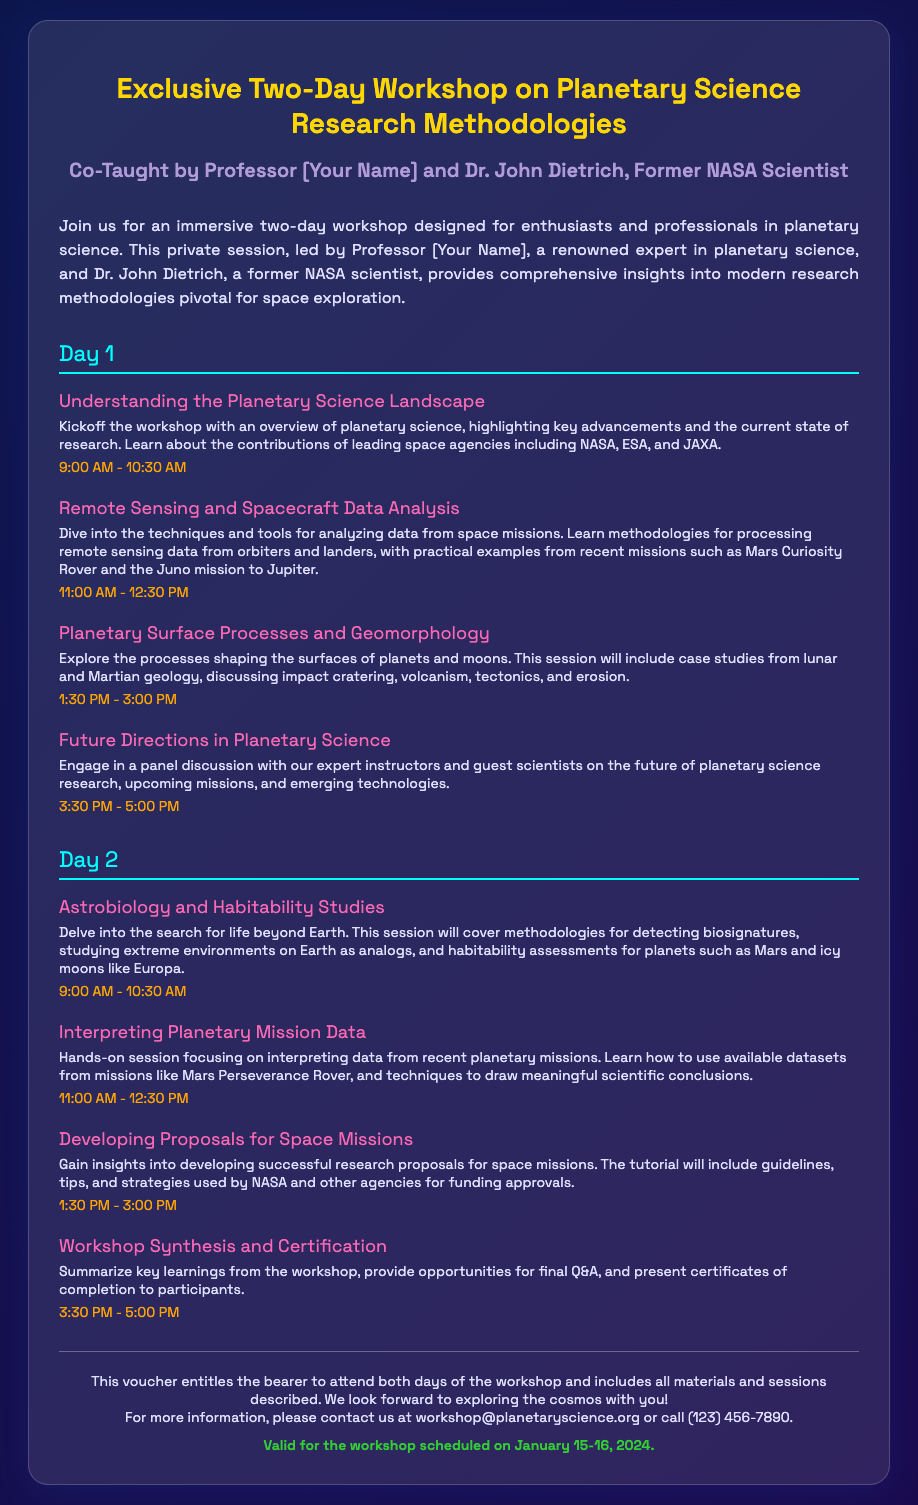What is the title of the workshop? The title of the workshop is prominently displayed at the top of the voucher, highlighting its focus on planetary science research methodologies.
Answer: Exclusive Two-Day Workshop on Planetary Science Research Methodologies Who are the instructors for the workshop? The instructors are mentioned in the subtitle, emphasizing their expertise and background, including the former NASA scientist.
Answer: Professor [Your Name] and Dr. John Dietrich What are the dates of the workshop? The validity of the voucher specifies the scheduled dates for the workshop, providing clarity on when it will occur.
Answer: January 15-16, 2024 How long does each session typically last? The session durations are stated, and the common length for each session can be inferred from this information.
Answer: 1.5 hours What is covered in the session on Day 1 at 1:30 PM? The description under this session time provides details on the topic being discussed, focusing on planetary processes.
Answer: Planetary Surface Processes and Geomorphology What type of session is provided at the end of Day 2? The concluding session of the second day is highlighted, summarizing the workshop and discussing what participants will receive.
Answer: Workshop Synthesis and Certification What is the email address for more information? The footer of the voucher includes contact information for inquiries, specifying how participants can reach out for further questions.
Answer: workshop@planetaryscience.org How many sessions are there on Day 2? By enumerating the sessions listed for Day 2, an overall count can be determined.
Answer: Four sessions What is included with the voucher? The footer explains the contents of the voucher, detailing what participants will receive by attending.
Answer: All materials and sessions described 